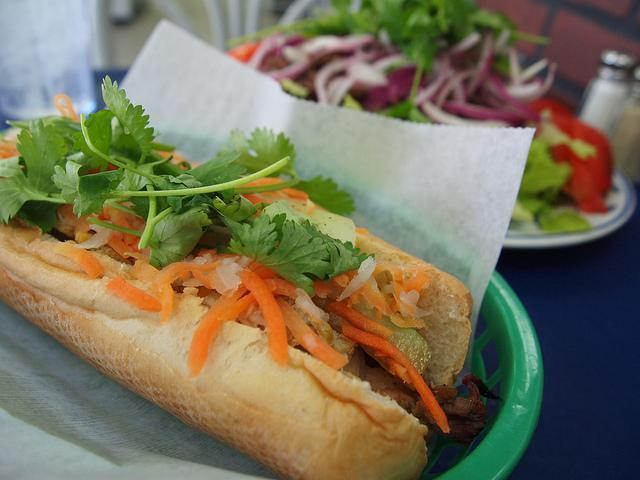How many carrots are in the picture?
Give a very brief answer. 3. How many bowls are there?
Give a very brief answer. 1. 